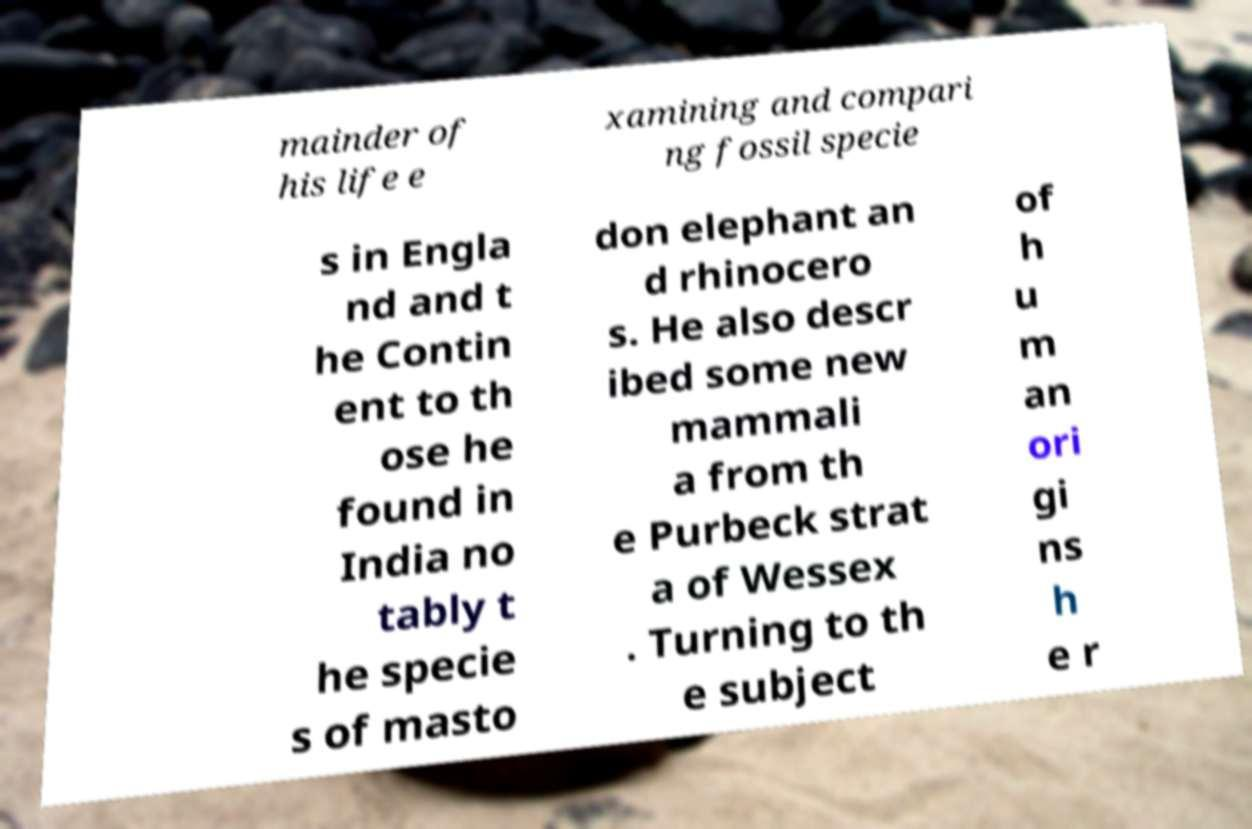There's text embedded in this image that I need extracted. Can you transcribe it verbatim? mainder of his life e xamining and compari ng fossil specie s in Engla nd and t he Contin ent to th ose he found in India no tably t he specie s of masto don elephant an d rhinocero s. He also descr ibed some new mammali a from th e Purbeck strat a of Wessex . Turning to th e subject of h u m an ori gi ns h e r 